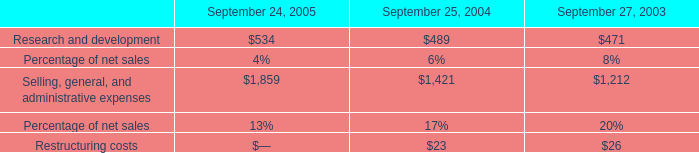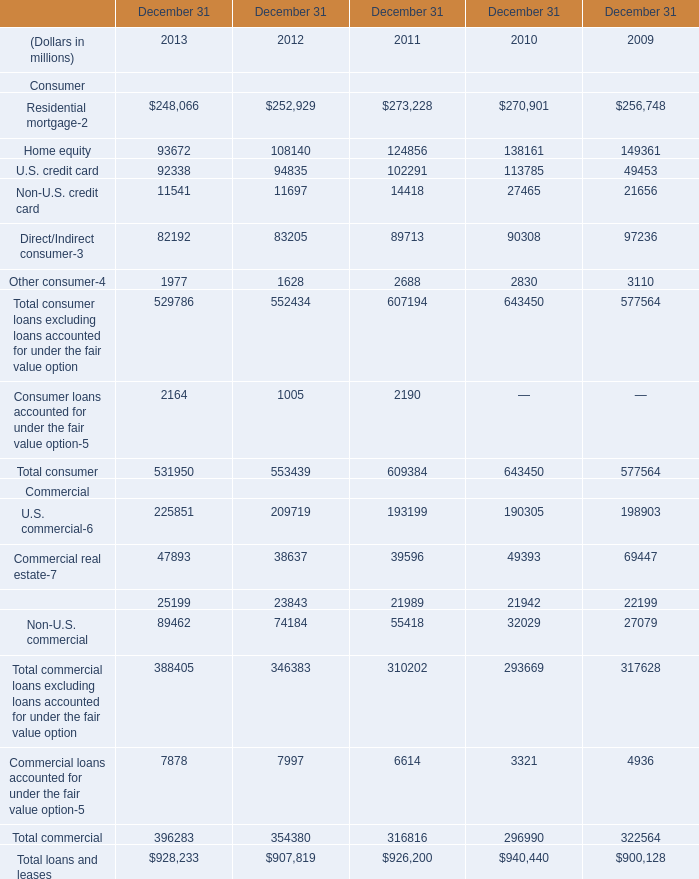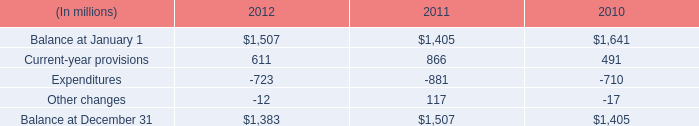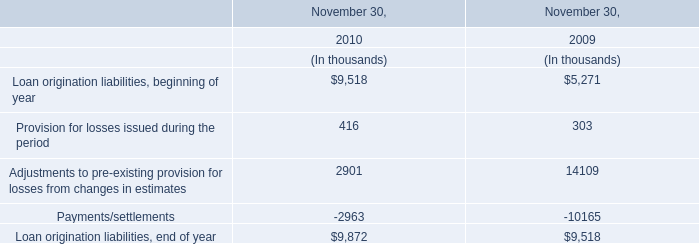What is the growing rate of Provision for losses issued during the period in Table 3 in the years with the least Current-year provisions in Table 2? 
Computations: ((416 - 303) / 303)
Answer: 0.37294. 